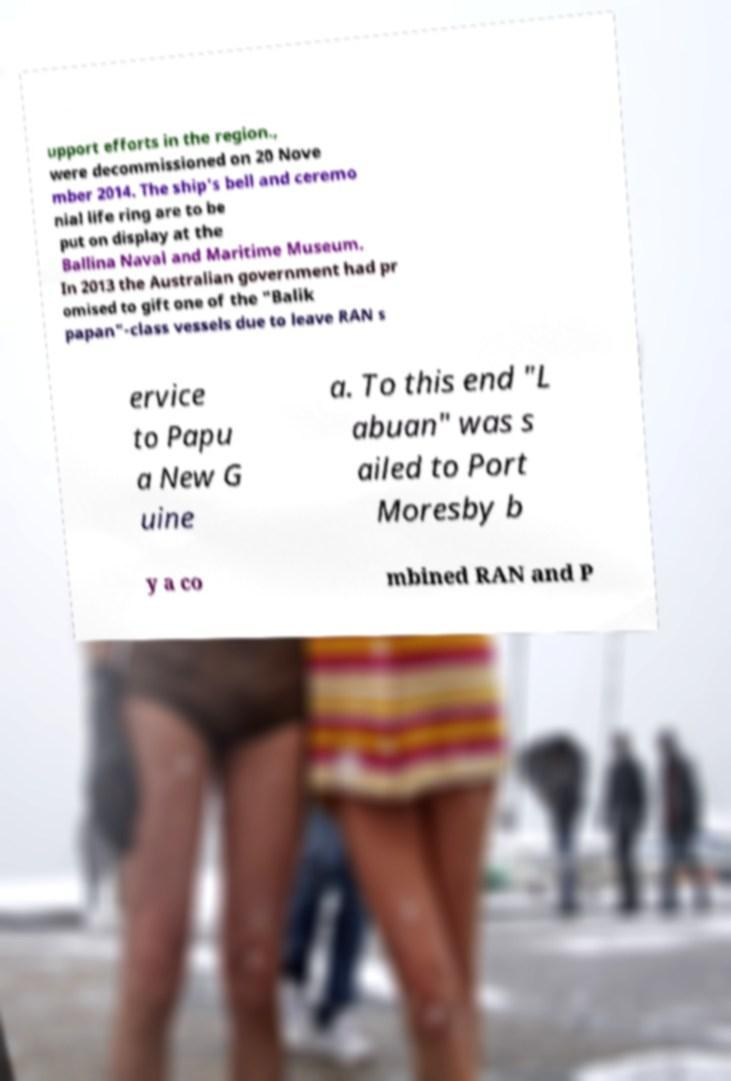Please read and relay the text visible in this image. What does it say? upport efforts in the region., were decommissioned on 20 Nove mber 2014. The ship's bell and ceremo nial life ring are to be put on display at the Ballina Naval and Maritime Museum. In 2013 the Australian government had pr omised to gift one of the "Balik papan"-class vessels due to leave RAN s ervice to Papu a New G uine a. To this end "L abuan" was s ailed to Port Moresby b y a co mbined RAN and P 